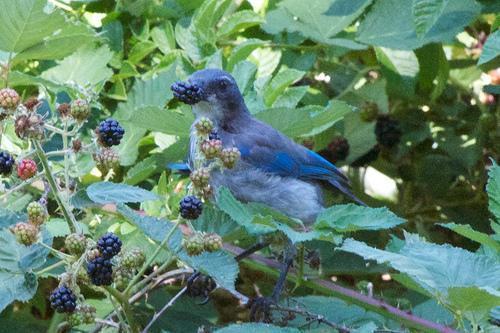How many birds are in the picture?
Give a very brief answer. 1. 